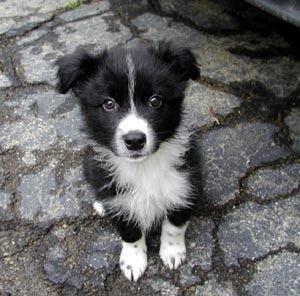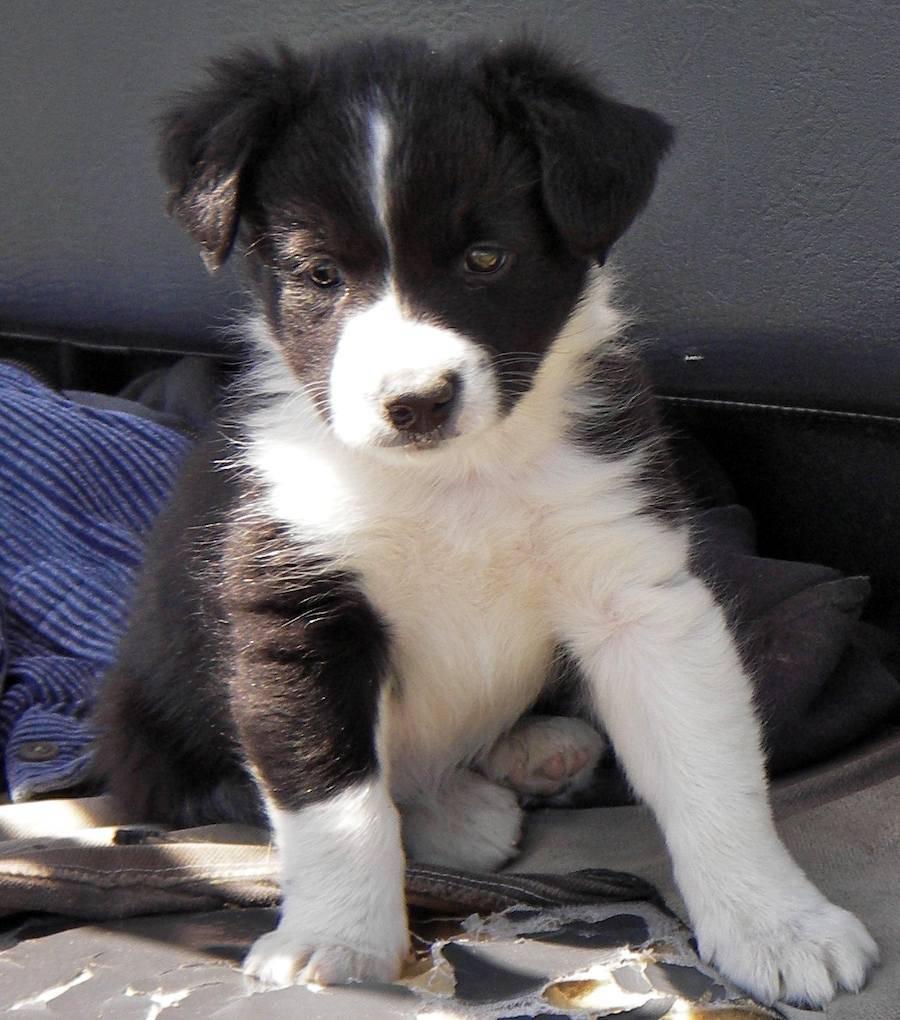The first image is the image on the left, the second image is the image on the right. Assess this claim about the two images: "Both images contain only one dog.". Correct or not? Answer yes or no. Yes. The first image is the image on the left, the second image is the image on the right. For the images shown, is this caption "There are four puppies in the pair of images." true? Answer yes or no. No. 